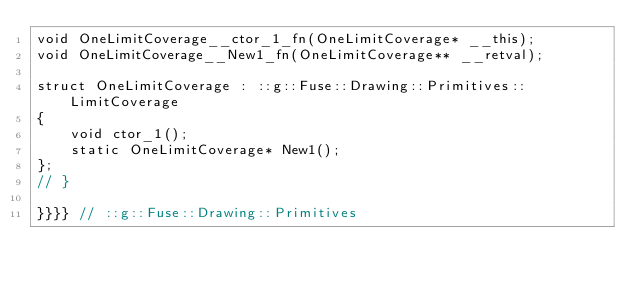Convert code to text. <code><loc_0><loc_0><loc_500><loc_500><_C_>void OneLimitCoverage__ctor_1_fn(OneLimitCoverage* __this);
void OneLimitCoverage__New1_fn(OneLimitCoverage** __retval);

struct OneLimitCoverage : ::g::Fuse::Drawing::Primitives::LimitCoverage
{
    void ctor_1();
    static OneLimitCoverage* New1();
};
// }

}}}} // ::g::Fuse::Drawing::Primitives
</code> 